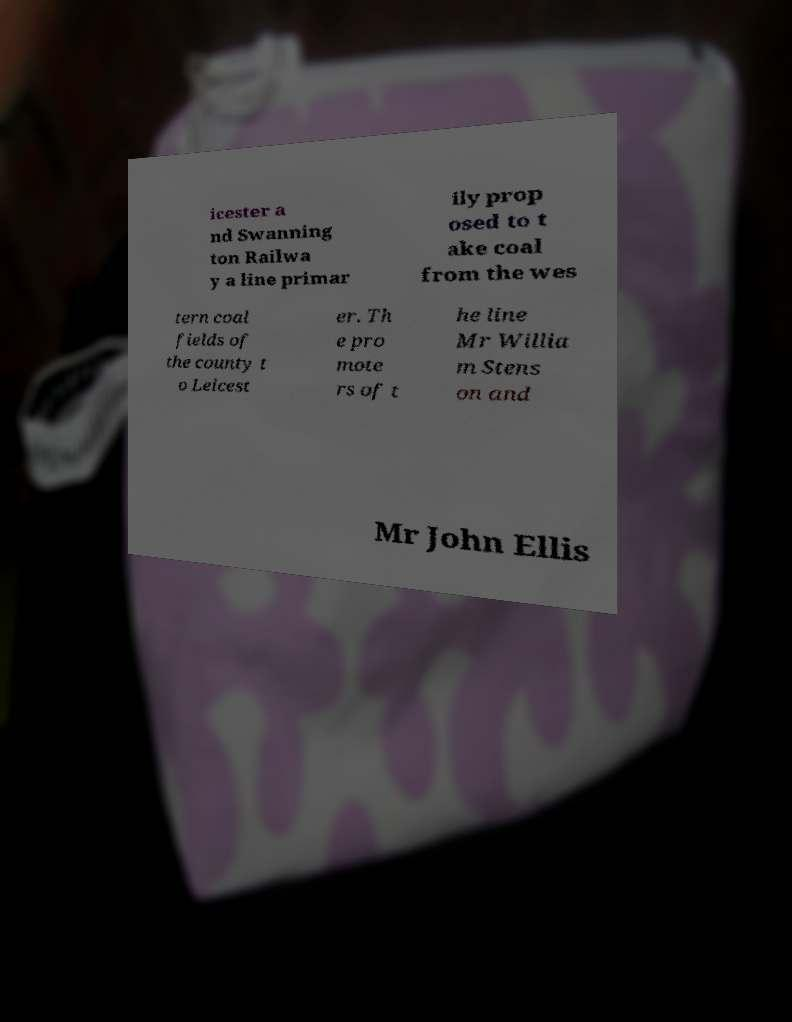There's text embedded in this image that I need extracted. Can you transcribe it verbatim? icester a nd Swanning ton Railwa y a line primar ily prop osed to t ake coal from the wes tern coal fields of the county t o Leicest er. Th e pro mote rs of t he line Mr Willia m Stens on and Mr John Ellis 